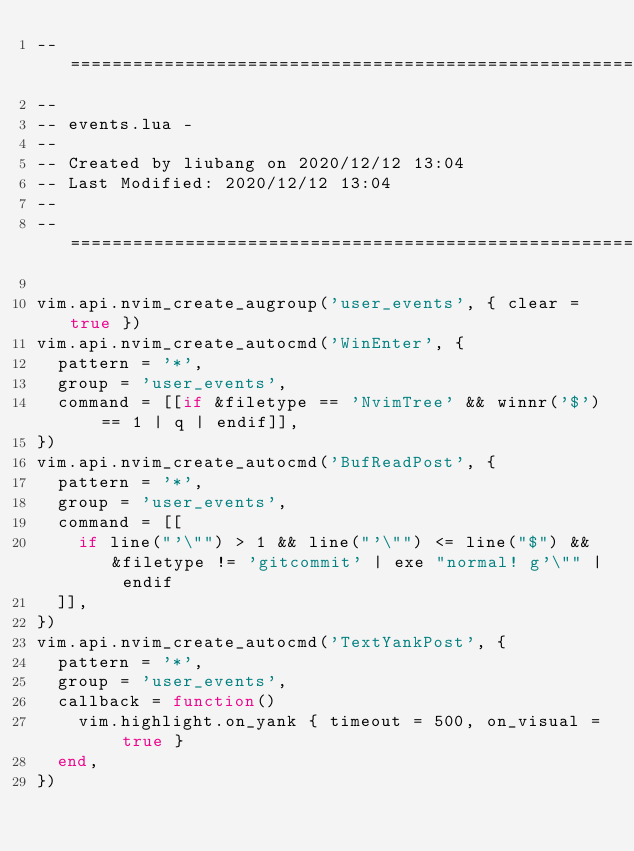<code> <loc_0><loc_0><loc_500><loc_500><_Lua_>-- =====================================================================
--
-- events.lua -
--
-- Created by liubang on 2020/12/12 13:04
-- Last Modified: 2020/12/12 13:04
--
-- =====================================================================

vim.api.nvim_create_augroup('user_events', { clear = true })
vim.api.nvim_create_autocmd('WinEnter', {
  pattern = '*',
  group = 'user_events',
  command = [[if &filetype == 'NvimTree' && winnr('$') == 1 | q | endif]],
})
vim.api.nvim_create_autocmd('BufReadPost', {
  pattern = '*',
  group = 'user_events',
  command = [[
    if line("'\"") > 1 && line("'\"") <= line("$") && &filetype != 'gitcommit' | exe "normal! g'\"" | endif
  ]],
})
vim.api.nvim_create_autocmd('TextYankPost', {
  pattern = '*',
  group = 'user_events',
  callback = function()
    vim.highlight.on_yank { timeout = 500, on_visual = true }
  end,
})
</code> 